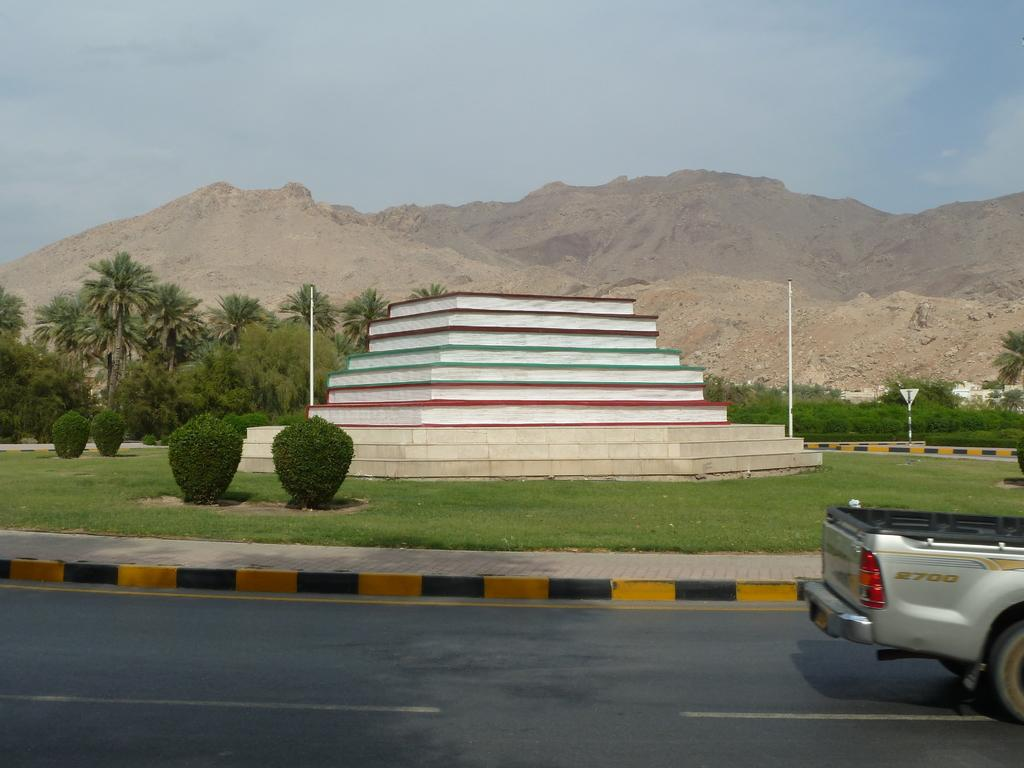<image>
Describe the image concisely. a truck with the numbers 2700 on its backside can be seen traveling down the road 